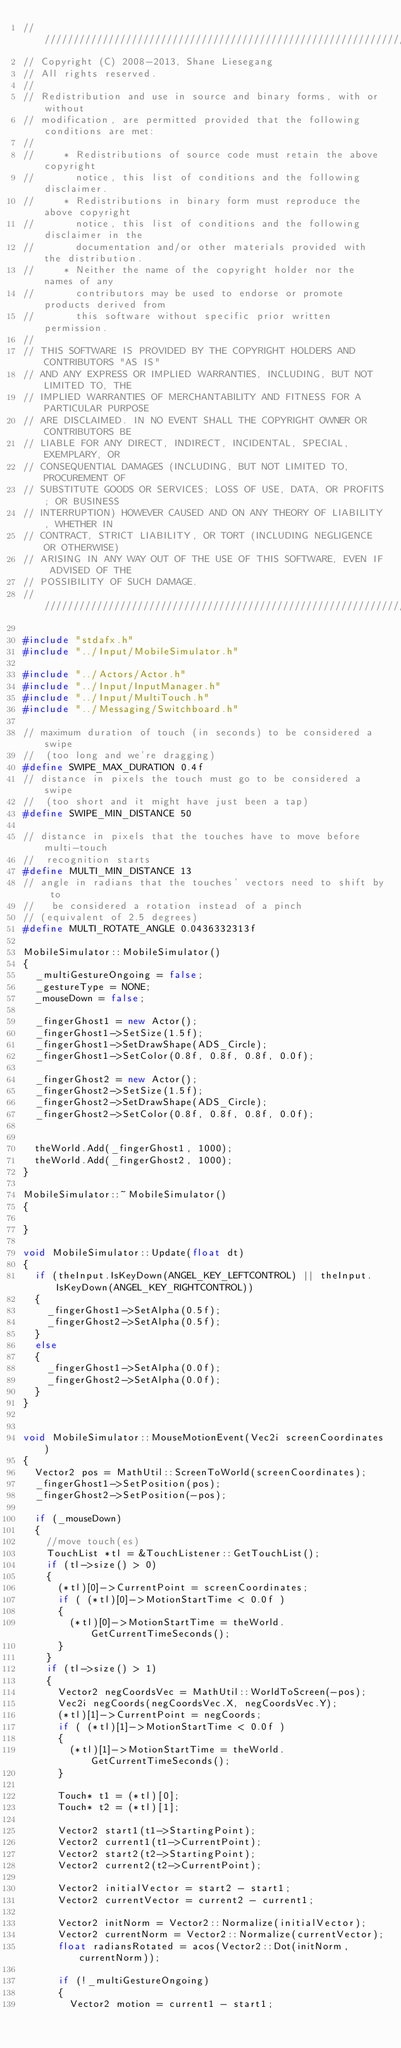Convert code to text. <code><loc_0><loc_0><loc_500><loc_500><_C++_>//////////////////////////////////////////////////////////////////////////////
// Copyright (C) 2008-2013, Shane Liesegang
// All rights reserved.
// 
// Redistribution and use in source and binary forms, with or without 
// modification, are permitted provided that the following conditions are met:
// 
//     * Redistributions of source code must retain the above copyright 
//       notice, this list of conditions and the following disclaimer.
//     * Redistributions in binary form must reproduce the above copyright 
//       notice, this list of conditions and the following disclaimer in the 
//       documentation and/or other materials provided with the distribution.
//     * Neither the name of the copyright holder nor the names of any 
//       contributors may be used to endorse or promote products derived from 
//       this software without specific prior written permission.
// 
// THIS SOFTWARE IS PROVIDED BY THE COPYRIGHT HOLDERS AND CONTRIBUTORS "AS IS" 
// AND ANY EXPRESS OR IMPLIED WARRANTIES, INCLUDING, BUT NOT LIMITED TO, THE 
// IMPLIED WARRANTIES OF MERCHANTABILITY AND FITNESS FOR A PARTICULAR PURPOSE 
// ARE DISCLAIMED. IN NO EVENT SHALL THE COPYRIGHT OWNER OR CONTRIBUTORS BE 
// LIABLE FOR ANY DIRECT, INDIRECT, INCIDENTAL, SPECIAL, EXEMPLARY, OR 
// CONSEQUENTIAL DAMAGES (INCLUDING, BUT NOT LIMITED TO, PROCUREMENT OF 
// SUBSTITUTE GOODS OR SERVICES; LOSS OF USE, DATA, OR PROFITS; OR BUSINESS 
// INTERRUPTION) HOWEVER CAUSED AND ON ANY THEORY OF LIABILITY, WHETHER IN 
// CONTRACT, STRICT LIABILITY, OR TORT (INCLUDING NEGLIGENCE OR OTHERWISE) 
// ARISING IN ANY WAY OUT OF THE USE OF THIS SOFTWARE, EVEN IF ADVISED OF THE 
// POSSIBILITY OF SUCH DAMAGE.
//////////////////////////////////////////////////////////////////////////////

#include "stdafx.h"
#include "../Input/MobileSimulator.h"

#include "../Actors/Actor.h"
#include "../Input/InputManager.h"
#include "../Input/MultiTouch.h"
#include "../Messaging/Switchboard.h"

// maximum duration of touch (in seconds) to be considered a swipe
//  (too long and we're dragging)
#define SWIPE_MAX_DURATION 0.4f
// distance in pixels the touch must go to be considered a swipe
//  (too short and it might have just been a tap)
#define SWIPE_MIN_DISTANCE 50

// distance in pixels that the touches have to move before multi-touch
//  recognition starts
#define MULTI_MIN_DISTANCE 13
// angle in radians that the touches' vectors need to shift by to
//   be considered a rotation instead of a pinch
// (equivalent of 2.5 degrees)
#define MULTI_ROTATE_ANGLE 0.0436332313f

MobileSimulator::MobileSimulator()
{
	_multiGestureOngoing = false;
	_gestureType = NONE;
	_mouseDown = false;

	_fingerGhost1 = new Actor();
	_fingerGhost1->SetSize(1.5f);
	_fingerGhost1->SetDrawShape(ADS_Circle);
	_fingerGhost1->SetColor(0.8f, 0.8f, 0.8f, 0.0f);

	_fingerGhost2 = new Actor();
	_fingerGhost2->SetSize(1.5f);
	_fingerGhost2->SetDrawShape(ADS_Circle);
	_fingerGhost2->SetColor(0.8f, 0.8f, 0.8f, 0.0f);


	theWorld.Add(_fingerGhost1, 1000);
	theWorld.Add(_fingerGhost2, 1000);
}

MobileSimulator::~MobileSimulator()
{
	
}

void MobileSimulator::Update(float dt)
{
	if (theInput.IsKeyDown(ANGEL_KEY_LEFTCONTROL) || theInput.IsKeyDown(ANGEL_KEY_RIGHTCONTROL))
	{
		_fingerGhost1->SetAlpha(0.5f);
		_fingerGhost2->SetAlpha(0.5f);
	}
	else
	{
		_fingerGhost1->SetAlpha(0.0f);
		_fingerGhost2->SetAlpha(0.0f);
	}
}


void MobileSimulator::MouseMotionEvent(Vec2i screenCoordinates)
{
	Vector2 pos = MathUtil::ScreenToWorld(screenCoordinates);
	_fingerGhost1->SetPosition(pos);
	_fingerGhost2->SetPosition(-pos);

	if (_mouseDown)
	{
		//move touch(es)
		TouchList *tl = &TouchListener::GetTouchList();
		if (tl->size() > 0)
		{
			(*tl)[0]->CurrentPoint = screenCoordinates;
			if ( (*tl)[0]->MotionStartTime < 0.0f )
			{
				(*tl)[0]->MotionStartTime = theWorld.GetCurrentTimeSeconds();
			}
		}
		if (tl->size() > 1)
		{
			Vector2 negCoordsVec = MathUtil::WorldToScreen(-pos);
			Vec2i negCoords(negCoordsVec.X, negCoordsVec.Y);
			(*tl)[1]->CurrentPoint = negCoords;
			if ( (*tl)[1]->MotionStartTime < 0.0f )
			{
				(*tl)[1]->MotionStartTime = theWorld.GetCurrentTimeSeconds();
			}

			Touch* t1 = (*tl)[0];
			Touch* t2 = (*tl)[1];

			Vector2 start1(t1->StartingPoint);
			Vector2 current1(t1->CurrentPoint);
			Vector2 start2(t2->StartingPoint);
			Vector2 current2(t2->CurrentPoint);

			Vector2 initialVector = start2 - start1;
			Vector2 currentVector = current2 - current1;

			Vector2 initNorm = Vector2::Normalize(initialVector);
			Vector2 currentNorm = Vector2::Normalize(currentVector);
			float radiansRotated = acos(Vector2::Dot(initNorm, currentNorm));

			if (!_multiGestureOngoing)
			{					
				Vector2 motion = current1 - start1;
</code> 